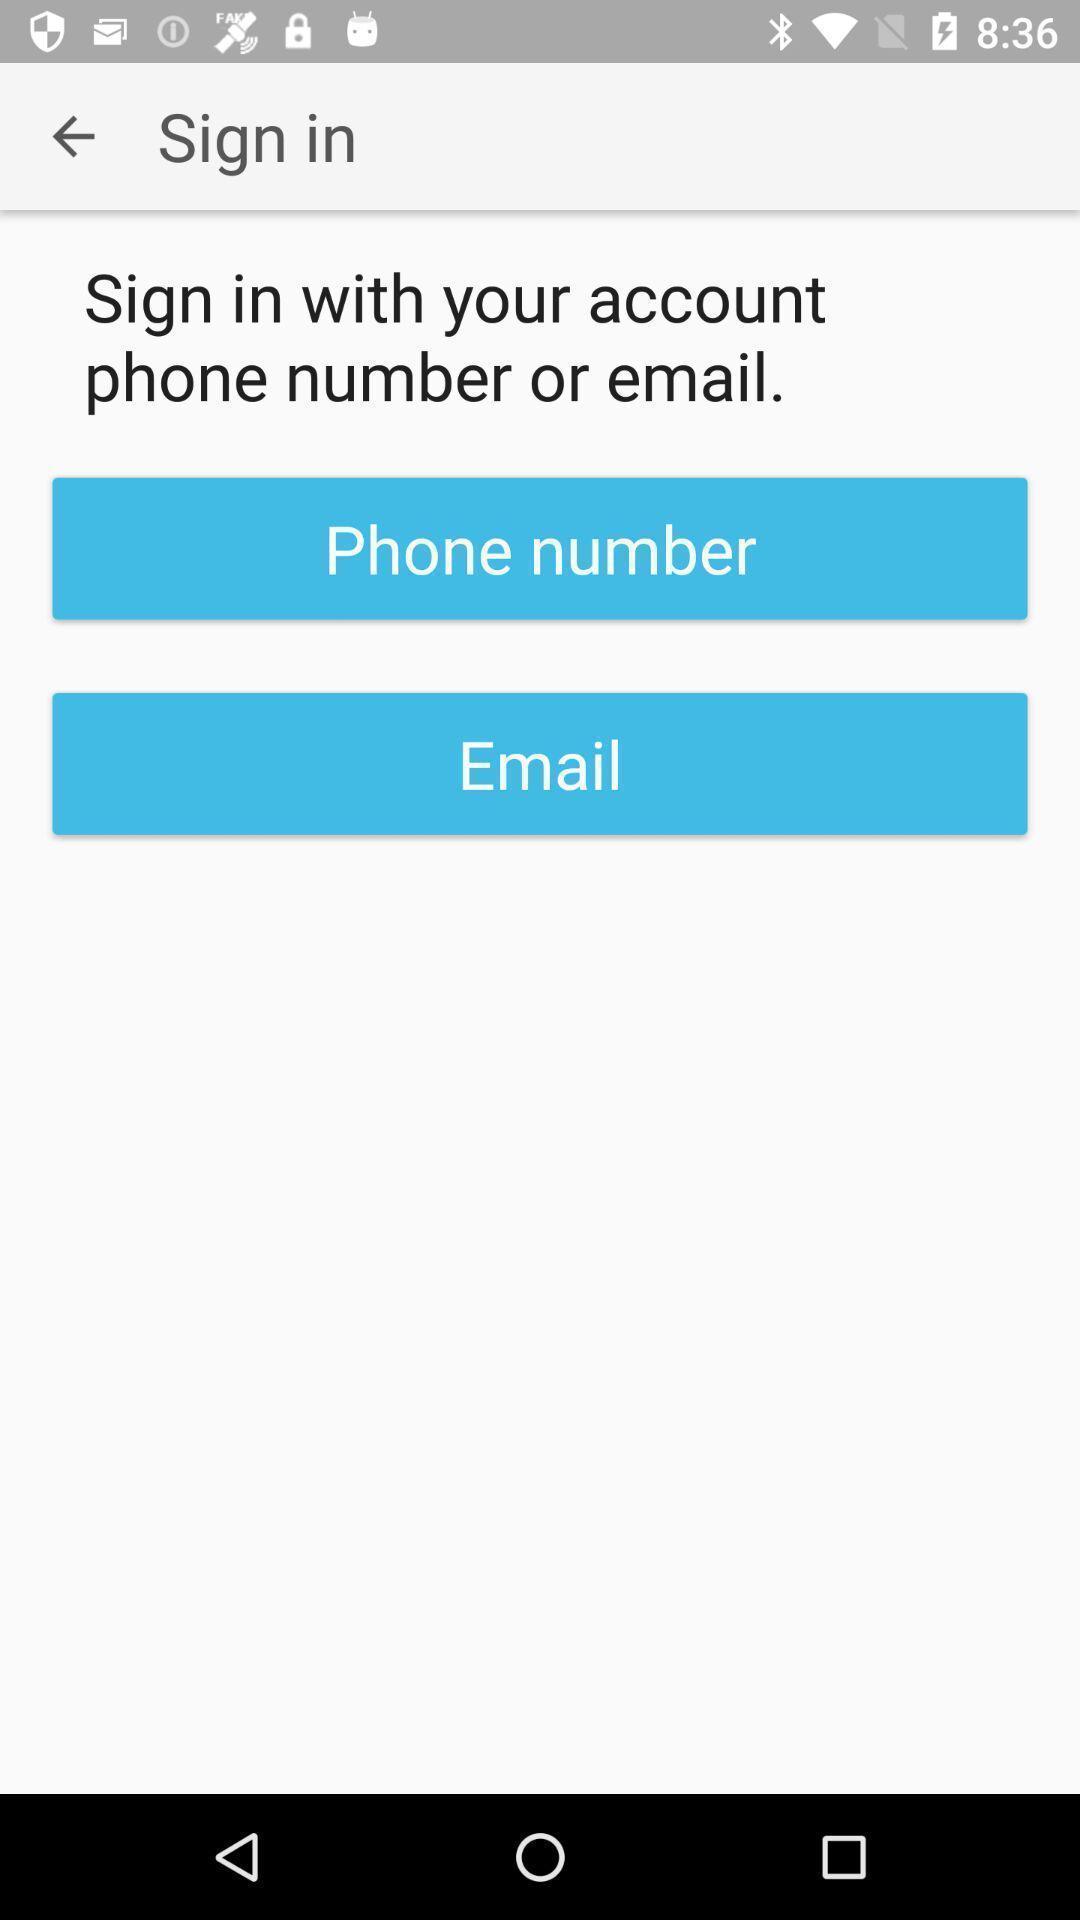Tell me about the visual elements in this screen capture. Sign in page with verification options. 